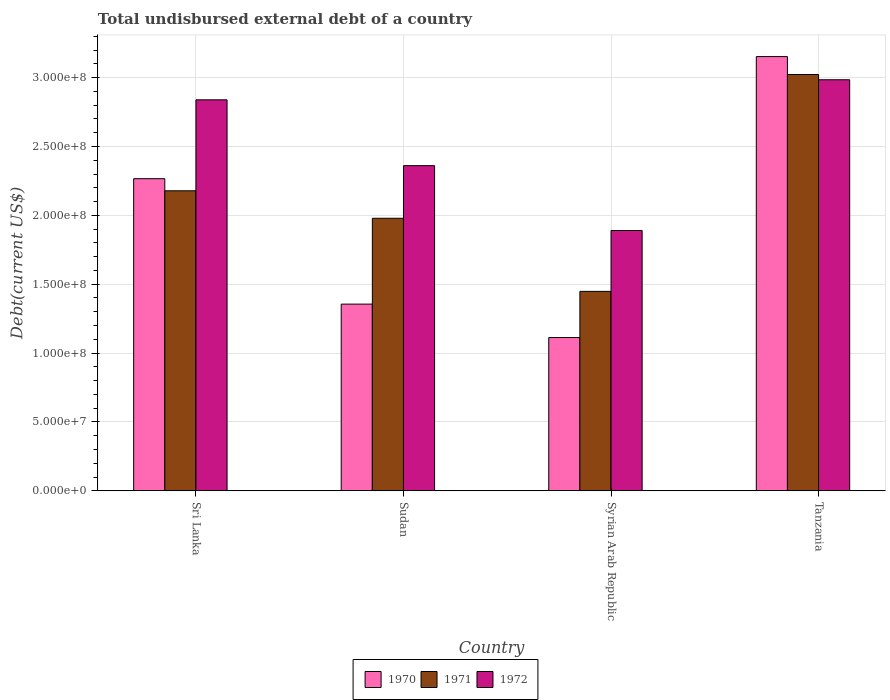How many different coloured bars are there?
Make the answer very short. 3. How many bars are there on the 4th tick from the left?
Give a very brief answer. 3. How many bars are there on the 4th tick from the right?
Provide a short and direct response. 3. What is the label of the 1st group of bars from the left?
Make the answer very short. Sri Lanka. In how many cases, is the number of bars for a given country not equal to the number of legend labels?
Your response must be concise. 0. What is the total undisbursed external debt in 1972 in Sri Lanka?
Offer a very short reply. 2.84e+08. Across all countries, what is the maximum total undisbursed external debt in 1970?
Give a very brief answer. 3.15e+08. Across all countries, what is the minimum total undisbursed external debt in 1971?
Provide a succinct answer. 1.45e+08. In which country was the total undisbursed external debt in 1972 maximum?
Give a very brief answer. Tanzania. In which country was the total undisbursed external debt in 1970 minimum?
Make the answer very short. Syrian Arab Republic. What is the total total undisbursed external debt in 1971 in the graph?
Offer a terse response. 8.63e+08. What is the difference between the total undisbursed external debt in 1970 in Syrian Arab Republic and that in Tanzania?
Make the answer very short. -2.04e+08. What is the difference between the total undisbursed external debt in 1970 in Sudan and the total undisbursed external debt in 1972 in Syrian Arab Republic?
Provide a short and direct response. -5.35e+07. What is the average total undisbursed external debt in 1972 per country?
Keep it short and to the point. 2.52e+08. What is the difference between the total undisbursed external debt of/in 1971 and total undisbursed external debt of/in 1972 in Sri Lanka?
Ensure brevity in your answer.  -6.61e+07. What is the ratio of the total undisbursed external debt in 1972 in Syrian Arab Republic to that in Tanzania?
Ensure brevity in your answer.  0.63. Is the total undisbursed external debt in 1970 in Sri Lanka less than that in Sudan?
Provide a short and direct response. No. What is the difference between the highest and the second highest total undisbursed external debt in 1970?
Offer a terse response. 8.87e+07. What is the difference between the highest and the lowest total undisbursed external debt in 1971?
Your answer should be very brief. 1.57e+08. In how many countries, is the total undisbursed external debt in 1972 greater than the average total undisbursed external debt in 1972 taken over all countries?
Provide a succinct answer. 2. What does the 2nd bar from the left in Tanzania represents?
Give a very brief answer. 1971. Is it the case that in every country, the sum of the total undisbursed external debt in 1970 and total undisbursed external debt in 1971 is greater than the total undisbursed external debt in 1972?
Provide a succinct answer. Yes. How many bars are there?
Ensure brevity in your answer.  12. Are all the bars in the graph horizontal?
Ensure brevity in your answer.  No. How many countries are there in the graph?
Ensure brevity in your answer.  4. Does the graph contain any zero values?
Ensure brevity in your answer.  No. Does the graph contain grids?
Offer a terse response. Yes. How are the legend labels stacked?
Keep it short and to the point. Horizontal. What is the title of the graph?
Ensure brevity in your answer.  Total undisbursed external debt of a country. Does "1965" appear as one of the legend labels in the graph?
Provide a succinct answer. No. What is the label or title of the Y-axis?
Ensure brevity in your answer.  Debt(current US$). What is the Debt(current US$) in 1970 in Sri Lanka?
Provide a succinct answer. 2.27e+08. What is the Debt(current US$) of 1971 in Sri Lanka?
Your answer should be compact. 2.18e+08. What is the Debt(current US$) of 1972 in Sri Lanka?
Give a very brief answer. 2.84e+08. What is the Debt(current US$) in 1970 in Sudan?
Ensure brevity in your answer.  1.36e+08. What is the Debt(current US$) in 1971 in Sudan?
Provide a succinct answer. 1.98e+08. What is the Debt(current US$) in 1972 in Sudan?
Keep it short and to the point. 2.36e+08. What is the Debt(current US$) in 1970 in Syrian Arab Republic?
Provide a short and direct response. 1.11e+08. What is the Debt(current US$) of 1971 in Syrian Arab Republic?
Offer a terse response. 1.45e+08. What is the Debt(current US$) of 1972 in Syrian Arab Republic?
Your answer should be very brief. 1.89e+08. What is the Debt(current US$) of 1970 in Tanzania?
Offer a terse response. 3.15e+08. What is the Debt(current US$) in 1971 in Tanzania?
Give a very brief answer. 3.02e+08. What is the Debt(current US$) in 1972 in Tanzania?
Your answer should be compact. 2.98e+08. Across all countries, what is the maximum Debt(current US$) in 1970?
Ensure brevity in your answer.  3.15e+08. Across all countries, what is the maximum Debt(current US$) of 1971?
Give a very brief answer. 3.02e+08. Across all countries, what is the maximum Debt(current US$) in 1972?
Your answer should be compact. 2.98e+08. Across all countries, what is the minimum Debt(current US$) of 1970?
Your response must be concise. 1.11e+08. Across all countries, what is the minimum Debt(current US$) of 1971?
Ensure brevity in your answer.  1.45e+08. Across all countries, what is the minimum Debt(current US$) of 1972?
Give a very brief answer. 1.89e+08. What is the total Debt(current US$) in 1970 in the graph?
Your answer should be compact. 7.89e+08. What is the total Debt(current US$) of 1971 in the graph?
Make the answer very short. 8.63e+08. What is the total Debt(current US$) of 1972 in the graph?
Your answer should be compact. 1.01e+09. What is the difference between the Debt(current US$) of 1970 in Sri Lanka and that in Sudan?
Provide a succinct answer. 9.11e+07. What is the difference between the Debt(current US$) in 1971 in Sri Lanka and that in Sudan?
Provide a succinct answer. 2.00e+07. What is the difference between the Debt(current US$) of 1972 in Sri Lanka and that in Sudan?
Keep it short and to the point. 4.78e+07. What is the difference between the Debt(current US$) of 1970 in Sri Lanka and that in Syrian Arab Republic?
Offer a very short reply. 1.15e+08. What is the difference between the Debt(current US$) of 1971 in Sri Lanka and that in Syrian Arab Republic?
Your response must be concise. 7.30e+07. What is the difference between the Debt(current US$) of 1972 in Sri Lanka and that in Syrian Arab Republic?
Provide a short and direct response. 9.49e+07. What is the difference between the Debt(current US$) in 1970 in Sri Lanka and that in Tanzania?
Ensure brevity in your answer.  -8.87e+07. What is the difference between the Debt(current US$) in 1971 in Sri Lanka and that in Tanzania?
Your answer should be compact. -8.44e+07. What is the difference between the Debt(current US$) in 1972 in Sri Lanka and that in Tanzania?
Your answer should be compact. -1.46e+07. What is the difference between the Debt(current US$) in 1970 in Sudan and that in Syrian Arab Republic?
Give a very brief answer. 2.43e+07. What is the difference between the Debt(current US$) of 1971 in Sudan and that in Syrian Arab Republic?
Your response must be concise. 5.31e+07. What is the difference between the Debt(current US$) of 1972 in Sudan and that in Syrian Arab Republic?
Your response must be concise. 4.71e+07. What is the difference between the Debt(current US$) in 1970 in Sudan and that in Tanzania?
Keep it short and to the point. -1.80e+08. What is the difference between the Debt(current US$) of 1971 in Sudan and that in Tanzania?
Your response must be concise. -1.04e+08. What is the difference between the Debt(current US$) in 1972 in Sudan and that in Tanzania?
Ensure brevity in your answer.  -6.24e+07. What is the difference between the Debt(current US$) in 1970 in Syrian Arab Republic and that in Tanzania?
Give a very brief answer. -2.04e+08. What is the difference between the Debt(current US$) of 1971 in Syrian Arab Republic and that in Tanzania?
Give a very brief answer. -1.57e+08. What is the difference between the Debt(current US$) of 1972 in Syrian Arab Republic and that in Tanzania?
Ensure brevity in your answer.  -1.09e+08. What is the difference between the Debt(current US$) in 1970 in Sri Lanka and the Debt(current US$) in 1971 in Sudan?
Your answer should be compact. 2.87e+07. What is the difference between the Debt(current US$) of 1970 in Sri Lanka and the Debt(current US$) of 1972 in Sudan?
Give a very brief answer. -9.47e+06. What is the difference between the Debt(current US$) of 1971 in Sri Lanka and the Debt(current US$) of 1972 in Sudan?
Offer a terse response. -1.82e+07. What is the difference between the Debt(current US$) in 1970 in Sri Lanka and the Debt(current US$) in 1971 in Syrian Arab Republic?
Your answer should be compact. 8.18e+07. What is the difference between the Debt(current US$) in 1970 in Sri Lanka and the Debt(current US$) in 1972 in Syrian Arab Republic?
Give a very brief answer. 3.76e+07. What is the difference between the Debt(current US$) in 1971 in Sri Lanka and the Debt(current US$) in 1972 in Syrian Arab Republic?
Keep it short and to the point. 2.88e+07. What is the difference between the Debt(current US$) in 1970 in Sri Lanka and the Debt(current US$) in 1971 in Tanzania?
Your answer should be very brief. -7.57e+07. What is the difference between the Debt(current US$) in 1970 in Sri Lanka and the Debt(current US$) in 1972 in Tanzania?
Your answer should be very brief. -7.18e+07. What is the difference between the Debt(current US$) in 1971 in Sri Lanka and the Debt(current US$) in 1972 in Tanzania?
Offer a very short reply. -8.06e+07. What is the difference between the Debt(current US$) of 1970 in Sudan and the Debt(current US$) of 1971 in Syrian Arab Republic?
Provide a short and direct response. -9.26e+06. What is the difference between the Debt(current US$) of 1970 in Sudan and the Debt(current US$) of 1972 in Syrian Arab Republic?
Your answer should be compact. -5.35e+07. What is the difference between the Debt(current US$) in 1971 in Sudan and the Debt(current US$) in 1972 in Syrian Arab Republic?
Provide a succinct answer. 8.87e+06. What is the difference between the Debt(current US$) of 1970 in Sudan and the Debt(current US$) of 1971 in Tanzania?
Give a very brief answer. -1.67e+08. What is the difference between the Debt(current US$) of 1970 in Sudan and the Debt(current US$) of 1972 in Tanzania?
Give a very brief answer. -1.63e+08. What is the difference between the Debt(current US$) of 1971 in Sudan and the Debt(current US$) of 1972 in Tanzania?
Ensure brevity in your answer.  -1.01e+08. What is the difference between the Debt(current US$) in 1970 in Syrian Arab Republic and the Debt(current US$) in 1971 in Tanzania?
Offer a terse response. -1.91e+08. What is the difference between the Debt(current US$) in 1970 in Syrian Arab Republic and the Debt(current US$) in 1972 in Tanzania?
Ensure brevity in your answer.  -1.87e+08. What is the difference between the Debt(current US$) of 1971 in Syrian Arab Republic and the Debt(current US$) of 1972 in Tanzania?
Give a very brief answer. -1.54e+08. What is the average Debt(current US$) in 1970 per country?
Provide a short and direct response. 1.97e+08. What is the average Debt(current US$) of 1971 per country?
Your response must be concise. 2.16e+08. What is the average Debt(current US$) of 1972 per country?
Ensure brevity in your answer.  2.52e+08. What is the difference between the Debt(current US$) in 1970 and Debt(current US$) in 1971 in Sri Lanka?
Your response must be concise. 8.78e+06. What is the difference between the Debt(current US$) in 1970 and Debt(current US$) in 1972 in Sri Lanka?
Make the answer very short. -5.73e+07. What is the difference between the Debt(current US$) in 1971 and Debt(current US$) in 1972 in Sri Lanka?
Provide a succinct answer. -6.61e+07. What is the difference between the Debt(current US$) in 1970 and Debt(current US$) in 1971 in Sudan?
Keep it short and to the point. -6.23e+07. What is the difference between the Debt(current US$) in 1970 and Debt(current US$) in 1972 in Sudan?
Make the answer very short. -1.01e+08. What is the difference between the Debt(current US$) in 1971 and Debt(current US$) in 1972 in Sudan?
Offer a very short reply. -3.82e+07. What is the difference between the Debt(current US$) in 1970 and Debt(current US$) in 1971 in Syrian Arab Republic?
Provide a short and direct response. -3.35e+07. What is the difference between the Debt(current US$) in 1970 and Debt(current US$) in 1972 in Syrian Arab Republic?
Your answer should be very brief. -7.77e+07. What is the difference between the Debt(current US$) of 1971 and Debt(current US$) of 1972 in Syrian Arab Republic?
Your response must be concise. -4.42e+07. What is the difference between the Debt(current US$) of 1970 and Debt(current US$) of 1971 in Tanzania?
Your answer should be compact. 1.30e+07. What is the difference between the Debt(current US$) in 1970 and Debt(current US$) in 1972 in Tanzania?
Ensure brevity in your answer.  1.68e+07. What is the difference between the Debt(current US$) in 1971 and Debt(current US$) in 1972 in Tanzania?
Your response must be concise. 3.82e+06. What is the ratio of the Debt(current US$) in 1970 in Sri Lanka to that in Sudan?
Your answer should be very brief. 1.67. What is the ratio of the Debt(current US$) of 1971 in Sri Lanka to that in Sudan?
Your answer should be compact. 1.1. What is the ratio of the Debt(current US$) of 1972 in Sri Lanka to that in Sudan?
Give a very brief answer. 1.2. What is the ratio of the Debt(current US$) in 1970 in Sri Lanka to that in Syrian Arab Republic?
Ensure brevity in your answer.  2.04. What is the ratio of the Debt(current US$) in 1971 in Sri Lanka to that in Syrian Arab Republic?
Make the answer very short. 1.5. What is the ratio of the Debt(current US$) of 1972 in Sri Lanka to that in Syrian Arab Republic?
Provide a short and direct response. 1.5. What is the ratio of the Debt(current US$) in 1970 in Sri Lanka to that in Tanzania?
Your answer should be compact. 0.72. What is the ratio of the Debt(current US$) of 1971 in Sri Lanka to that in Tanzania?
Give a very brief answer. 0.72. What is the ratio of the Debt(current US$) in 1972 in Sri Lanka to that in Tanzania?
Ensure brevity in your answer.  0.95. What is the ratio of the Debt(current US$) in 1970 in Sudan to that in Syrian Arab Republic?
Your response must be concise. 1.22. What is the ratio of the Debt(current US$) of 1971 in Sudan to that in Syrian Arab Republic?
Ensure brevity in your answer.  1.37. What is the ratio of the Debt(current US$) in 1972 in Sudan to that in Syrian Arab Republic?
Provide a succinct answer. 1.25. What is the ratio of the Debt(current US$) in 1970 in Sudan to that in Tanzania?
Provide a short and direct response. 0.43. What is the ratio of the Debt(current US$) in 1971 in Sudan to that in Tanzania?
Provide a short and direct response. 0.65. What is the ratio of the Debt(current US$) in 1972 in Sudan to that in Tanzania?
Your answer should be very brief. 0.79. What is the ratio of the Debt(current US$) in 1970 in Syrian Arab Republic to that in Tanzania?
Your answer should be very brief. 0.35. What is the ratio of the Debt(current US$) in 1971 in Syrian Arab Republic to that in Tanzania?
Your answer should be compact. 0.48. What is the ratio of the Debt(current US$) of 1972 in Syrian Arab Republic to that in Tanzania?
Provide a short and direct response. 0.63. What is the difference between the highest and the second highest Debt(current US$) of 1970?
Provide a short and direct response. 8.87e+07. What is the difference between the highest and the second highest Debt(current US$) in 1971?
Keep it short and to the point. 8.44e+07. What is the difference between the highest and the second highest Debt(current US$) of 1972?
Ensure brevity in your answer.  1.46e+07. What is the difference between the highest and the lowest Debt(current US$) in 1970?
Provide a short and direct response. 2.04e+08. What is the difference between the highest and the lowest Debt(current US$) in 1971?
Ensure brevity in your answer.  1.57e+08. What is the difference between the highest and the lowest Debt(current US$) of 1972?
Your answer should be compact. 1.09e+08. 